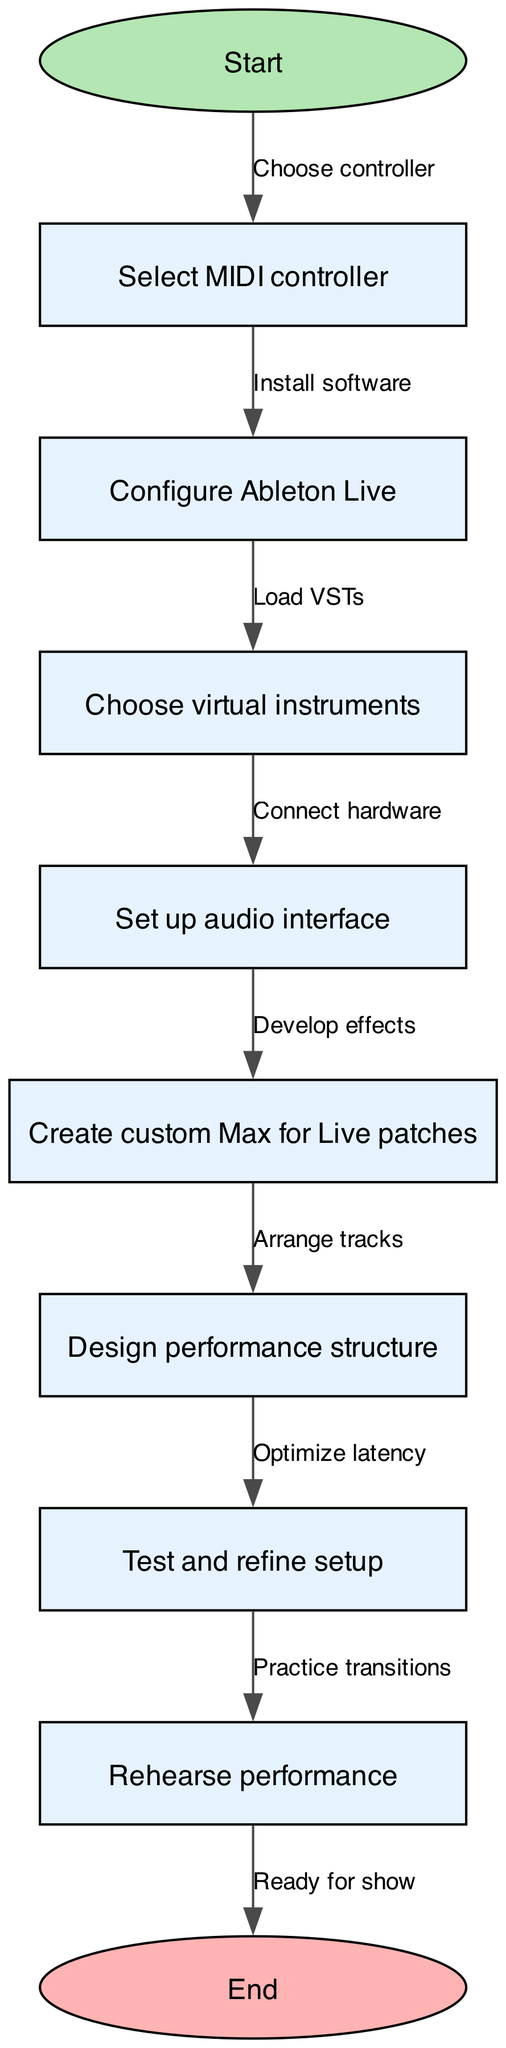What is the first step in the process? The first node in the flowchart is labeled "Start," indicating the beginning of the process.
Answer: Start How many nodes are present in the diagram? By counting each individual entry in the "nodes" list, there are a total of 10 unique nodes present in the diagram.
Answer: 10 What is the last step before the performance setup is complete? The final node before the "End" node is "Ready for show," which indicates the setup is complete and ready for performance.
Answer: Ready for show Which node follows "Test and refine setup"? The direct flow from "Test and refine setup" leads to the next node, "Rehearse performance."
Answer: Rehearse performance How many edges connect the nodes in the diagram? Each node, except the last one, has an outgoing edge leading to the next node, resulting in a total of 9 edges connecting these 10 nodes.
Answer: 9 What is the relationship between "Select MIDI controller" and "Connect hardware"? "Select MIDI controller" leads to the action of "Connect hardware," as these are part of the flow in setting up the performance.
Answer: Connect hardware Which step involves creating Max for Live patches? The node titled "Create custom Max for Live patches" specifically addresses the creation of patches within the performance setup process.
Answer: Create custom Max for Live patches What action takes place after "Design performance structure"? The next step in the process after "Design performance structure" is "Test and refine setup," indicating a review phase follows the design stage.
Answer: Test and refine setup In which step are virtual instruments chosen? The node labeled "Choose virtual instruments" indicates the selection of virtual instruments occurs during the setup process.
Answer: Choose virtual instruments 